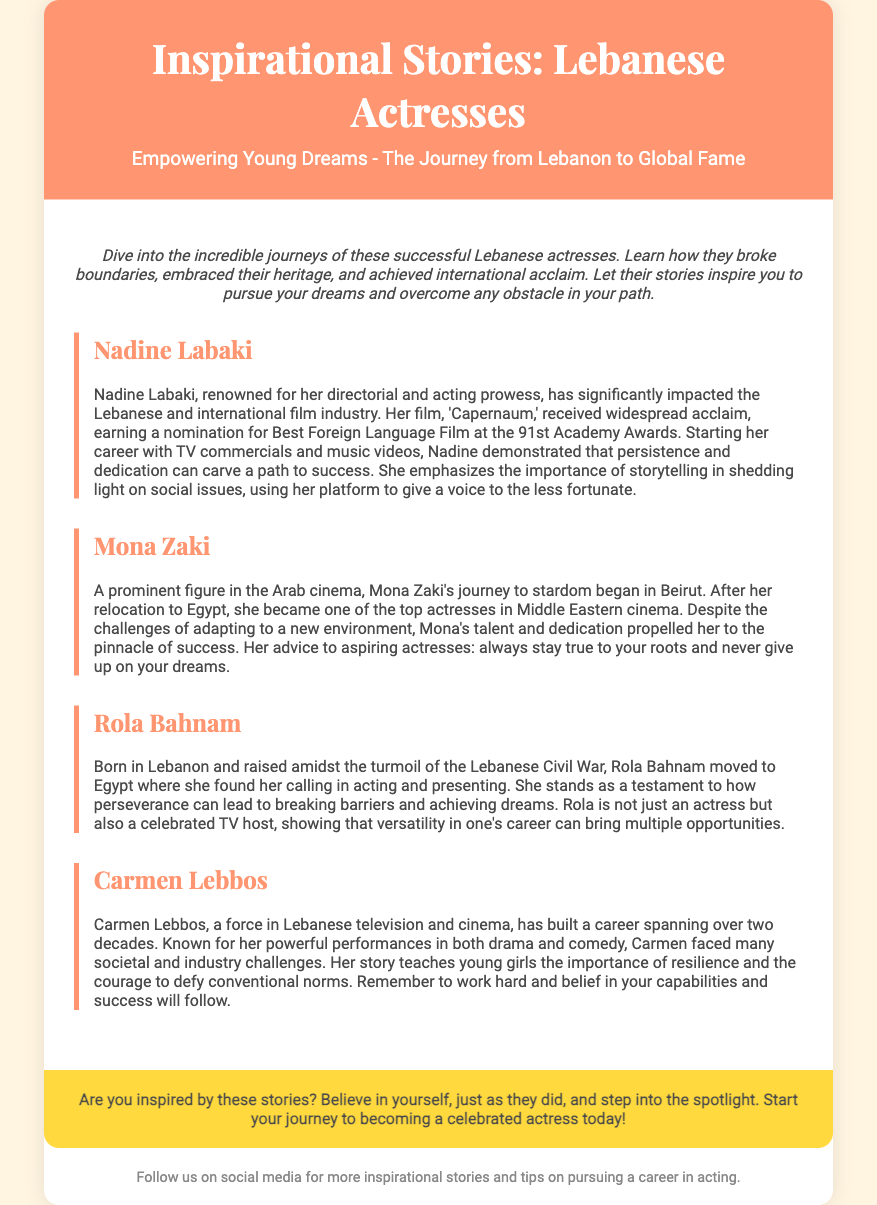What is the title of the flyer? The title is prominently displayed at the top of the flyer.
Answer: Inspirational Stories: Lebanese Actresses Who is the actress known for her film 'Capernaum'? The document highlights Nadine Labaki's achievements in the context of her renowned film.
Answer: Nadine Labaki Which actress moved to Egypt and became a top figure in Arab cinema? The document mentions Mona Zaki's journey began in Beirut and her success in Egypt.
Answer: Mona Zaki How many actresses are featured in the flyer? The document lists a total of four actresses in dedicated sections.
Answer: Four What is the primary theme emphasized by Mona Zaki for aspiring actresses? Mona Zaki's advice encourages staying true to one's roots and persistence.
Answer: Stay true to your roots What significant societal challenge did Rola Bahnam overcome? The document discusses her background during the Lebanese Civil War and her successful career post-migration.
Answer: Lebanese Civil War What years does Carmen Lebbos's career span according to the flyer? The document states her career has built over two decades without specifying years.
Answer: Over two decades What color is used in the flyer’s header? The color scheme in the header is described in the document.
Answer: #FF9671 (orange) 